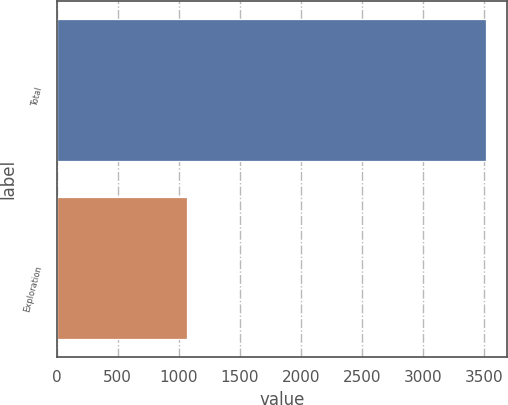<chart> <loc_0><loc_0><loc_500><loc_500><bar_chart><fcel>Total<fcel>Exploration<nl><fcel>3514<fcel>1067<nl></chart> 